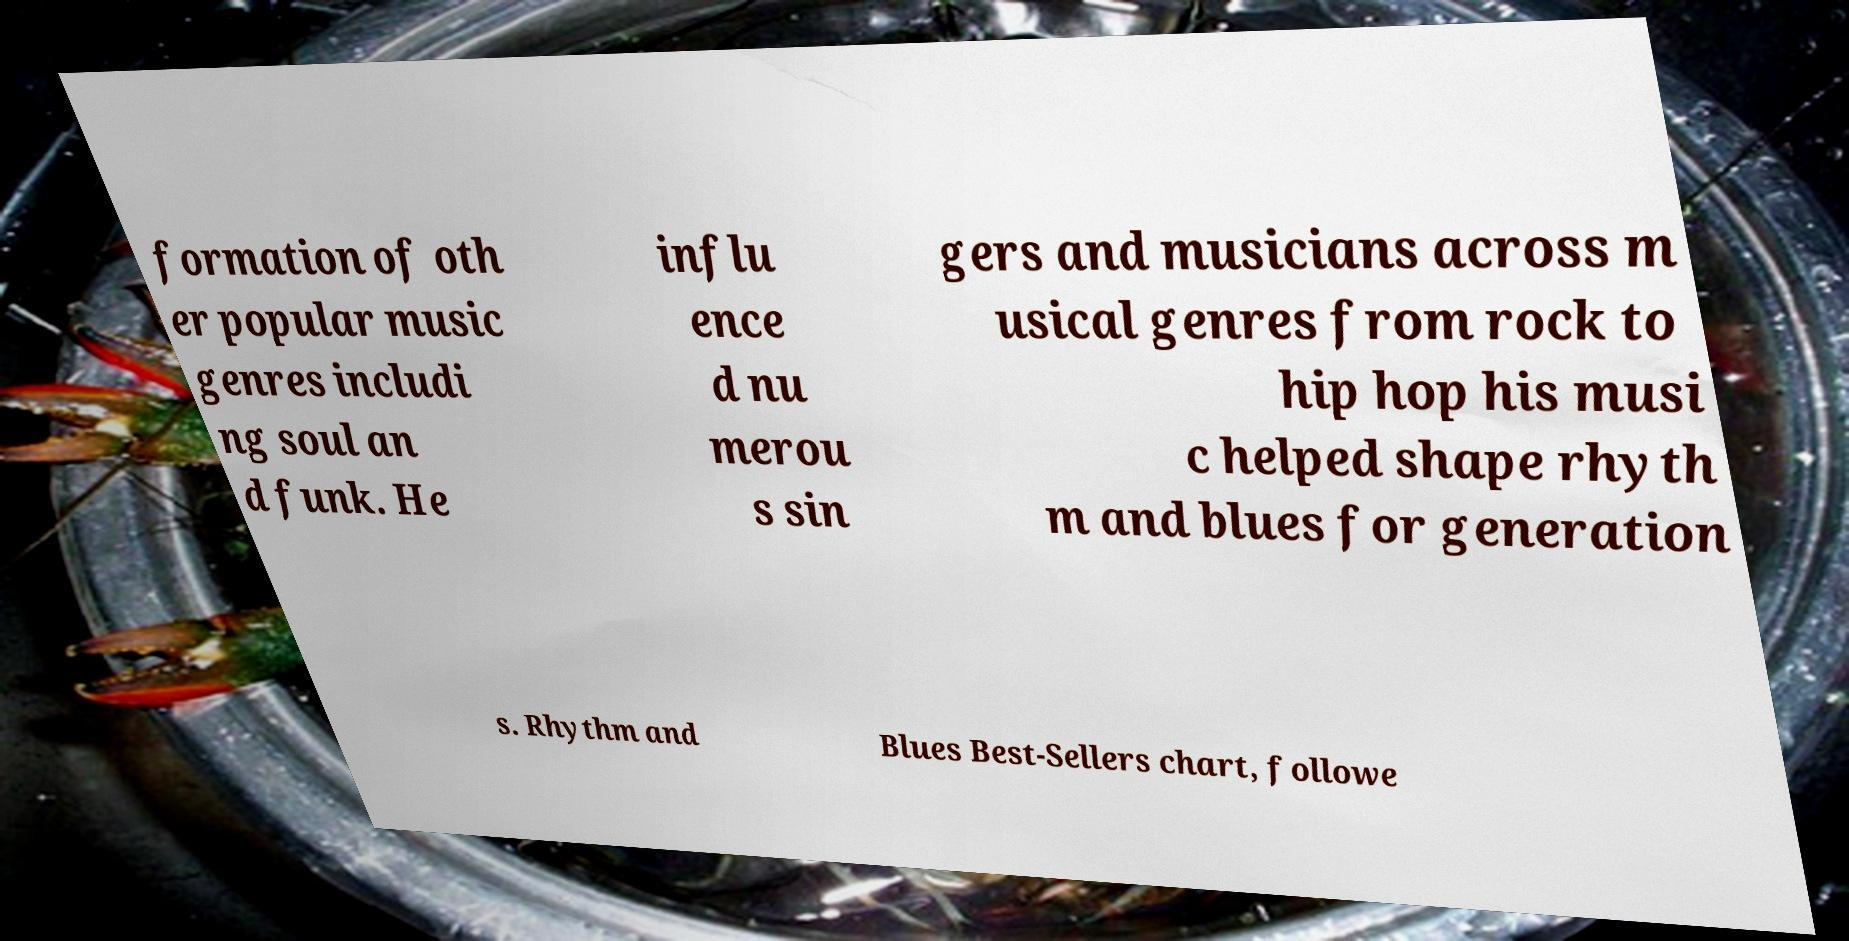Can you accurately transcribe the text from the provided image for me? formation of oth er popular music genres includi ng soul an d funk. He influ ence d nu merou s sin gers and musicians across m usical genres from rock to hip hop his musi c helped shape rhyth m and blues for generation s. Rhythm and Blues Best-Sellers chart, followe 